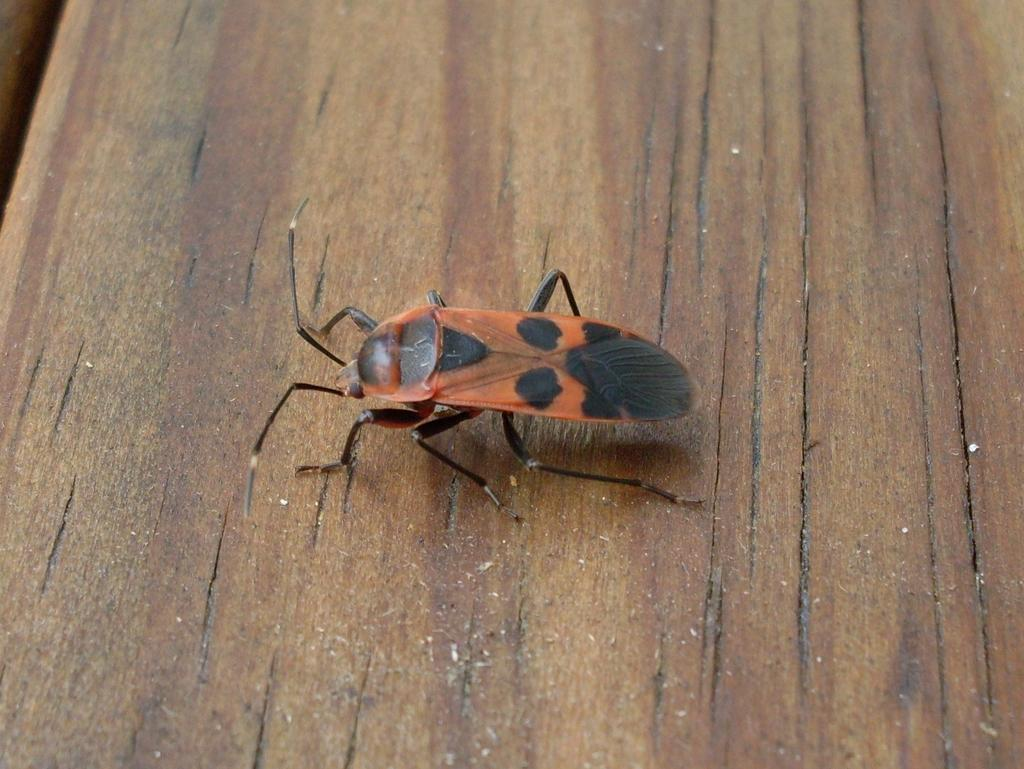What type of creature is present in the image? There is an insect in the image. What surface is the insect situated on? The insect is on a wooden surface. What type of steel structure can be seen in the image? There is no steel structure present in the image; it features an insect on a wooden surface. Can you tell me who the insect is arguing with in the image? There is no indication of an argument or any interaction between the insect and another creature in the image. 